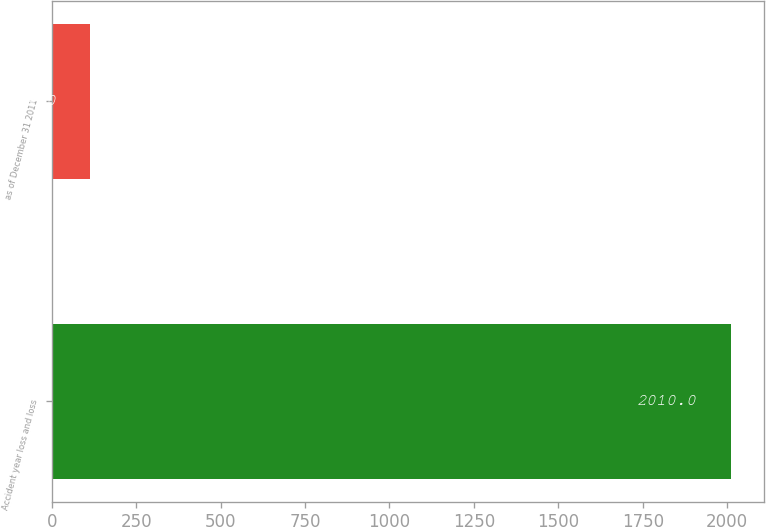<chart> <loc_0><loc_0><loc_500><loc_500><bar_chart><fcel>Accident year loss and loss<fcel>as of December 31 2011<nl><fcel>2010<fcel>114<nl></chart> 